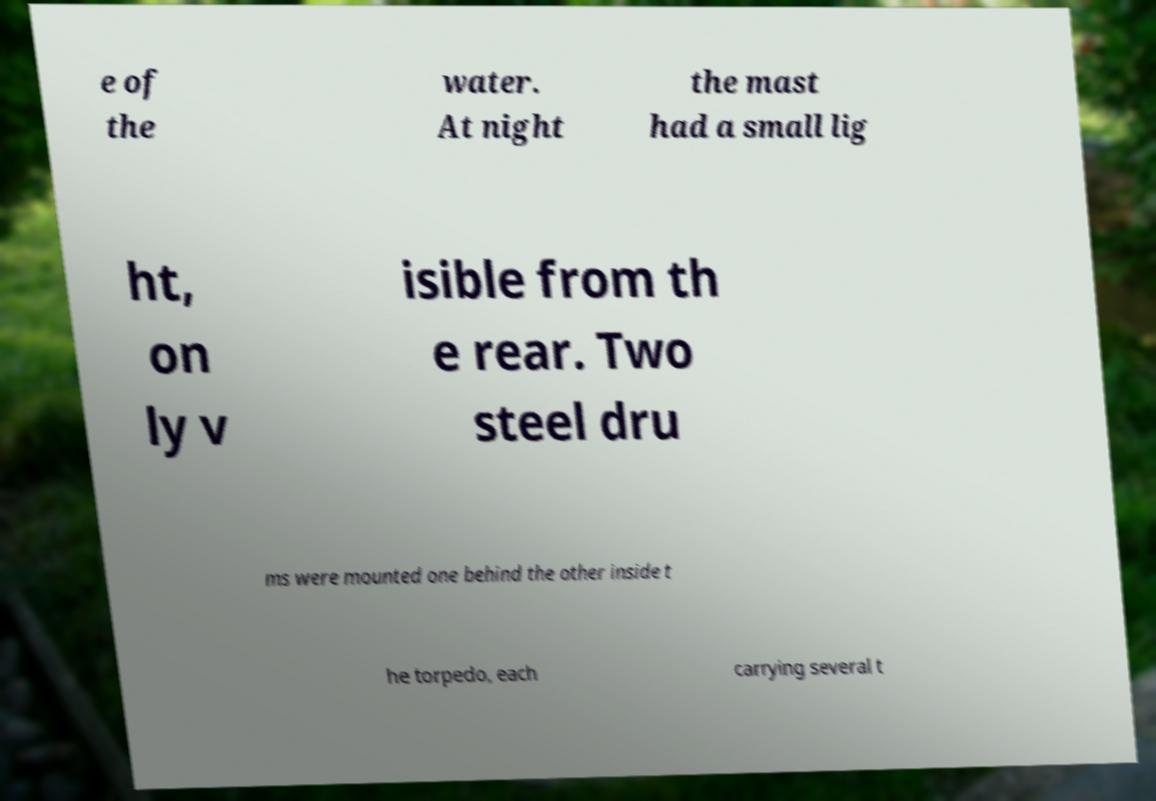Can you accurately transcribe the text from the provided image for me? e of the water. At night the mast had a small lig ht, on ly v isible from th e rear. Two steel dru ms were mounted one behind the other inside t he torpedo, each carrying several t 